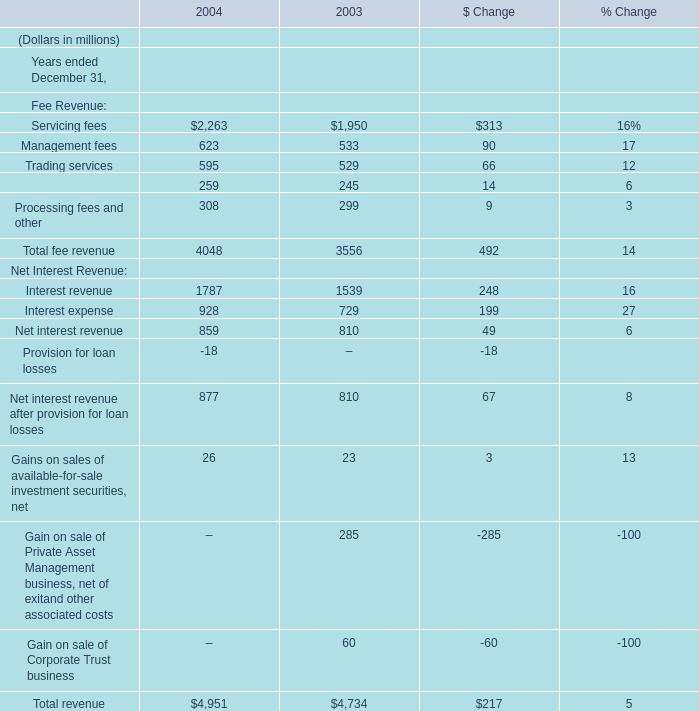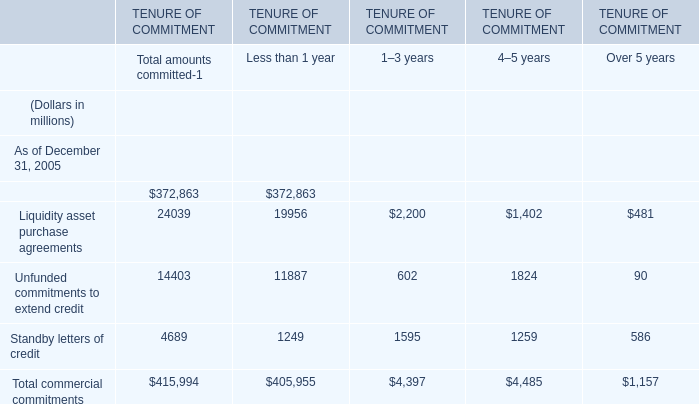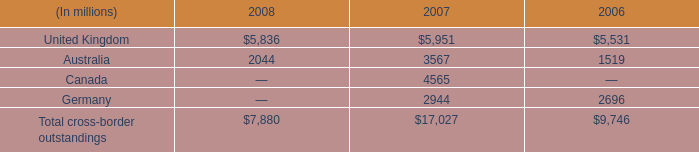what's the total amount of Liquidity asset purchase agreements of TENURE OF COMMITMENT 4–5 years, and United Kingdom of 2008 ? 
Computations: (1402.0 + 5836.0)
Answer: 7238.0. 